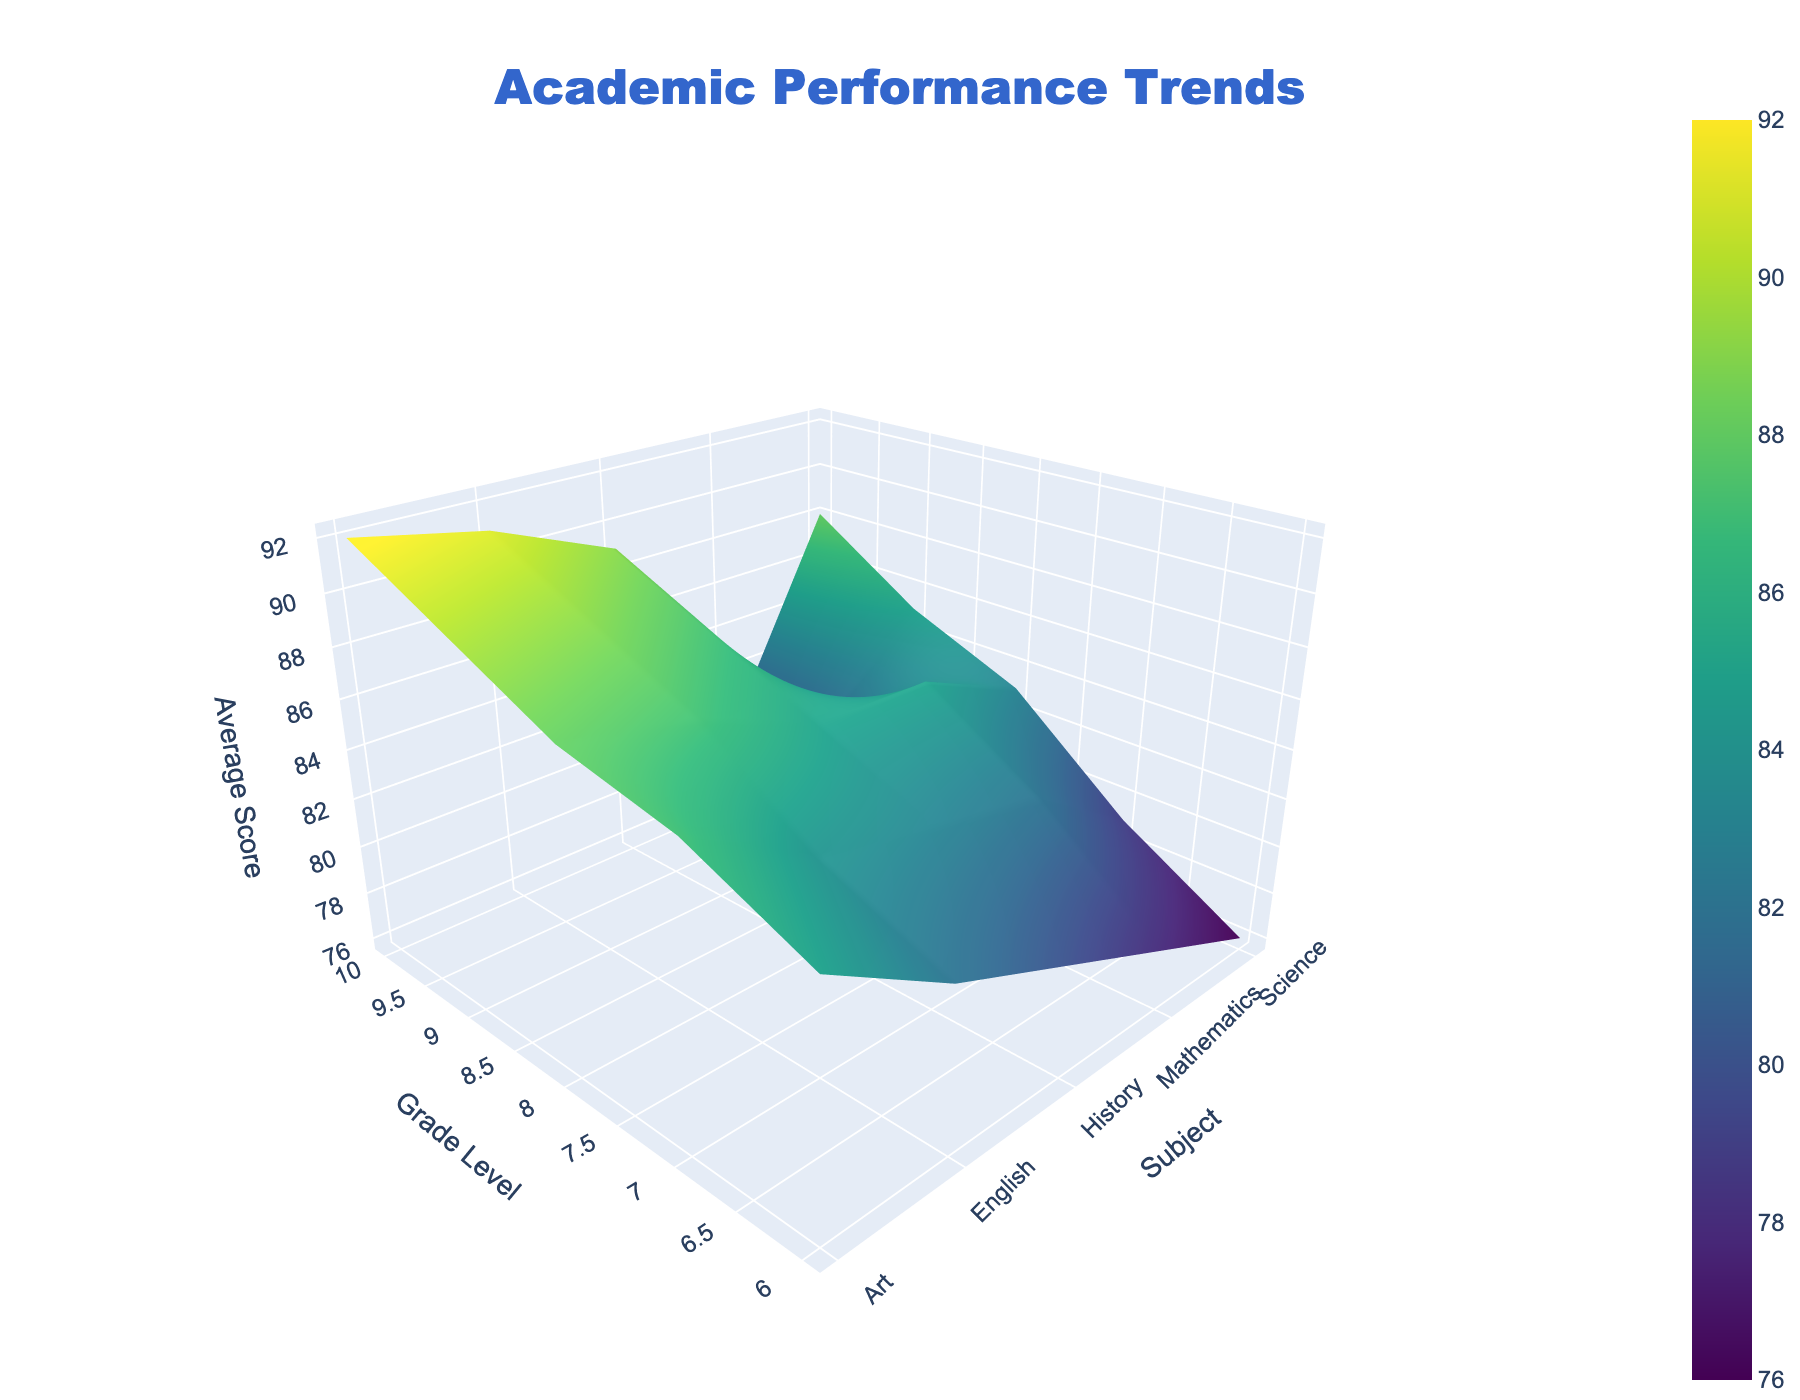What's the highest average score observed across all subjects and grade levels? From the 3D surface plot, look for the peak on the Z-axis. The highest peak corresponds to Art for Grade 10 with a score of 92.
Answer: 92 What is the general trend of average scores in Mathematics as students progress to higher grade levels? Observe the surface plot section corresponding to Mathematics. The average scores initially rise from Grade 6 to Grade 8, then slightly decline in Grades 9 and 10.
Answer: Rises initially, then declines Which subject shows the most consistent increase in average scores as grade levels go up? Look at each subject’s trend through the grade levels. English is a good example of showing a consistent increase.
Answer: English Which grade level has the highest overall average score across all subjects? Average the scores for each grade level across all subjects and identify the grade level with the highest average. Grade 10 averages are the highest.
Answer: Grade 10 Compare the average scores for Science and History in Grade 9. Which one is higher? Compare the Z-axis values for Science and History at Grade 9 points. Science has a score of 85, and History has 87.
Answer: History What is the difference in the average score between Grade 6 and Grade 10 for Mathematics? The Z-axis values for Mathematics are 78 for Grade 6 and 79 for Grade 10. The difference is 1 point.
Answer: 1 Which subject has the lowest average score in Grade 8? Check the Z-axis values for all subjects at the Grade 8 point. Science has the lowest with 83.
Answer: Science What colors are used to represent the highest average scores in the 3D plot? Identify the color corresponding to the highest peaks in the surface plot. These colors are generally shades of yellow in the Viridis colorscale.
Answer: Yellow Considering the Art subject, how much does the average score increase from Grade 6 to Grade 10? Observe the Z-axis values for Art in Grade 6 and 10, which are 85 and 92, respectively. The increase is 7 points.
Answer: 7 Which two subjects have the closest average scores in Grade 7? Compare the Z-axis values for all subjects at Grade 7. History and English are close with scores of 83 and 84, respectively.
Answer: History and English 